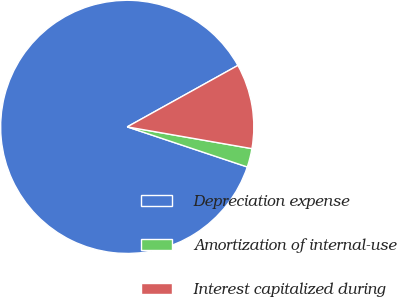<chart> <loc_0><loc_0><loc_500><loc_500><pie_chart><fcel>Depreciation expense<fcel>Amortization of internal-use<fcel>Interest capitalized during<nl><fcel>86.8%<fcel>2.38%<fcel>10.82%<nl></chart> 